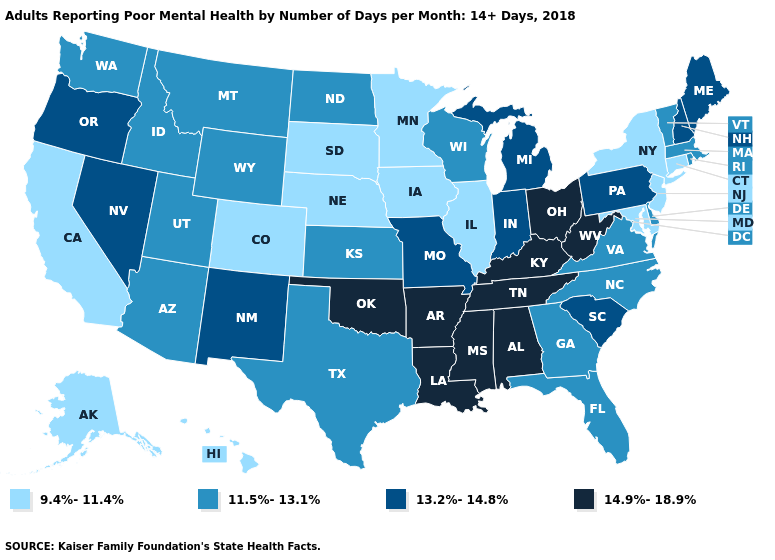Does Alabama have a lower value than Wisconsin?
Be succinct. No. What is the highest value in states that border Minnesota?
Quick response, please. 11.5%-13.1%. Does Hawaii have the same value as Minnesota?
Concise answer only. Yes. What is the value of Wyoming?
Concise answer only. 11.5%-13.1%. Name the states that have a value in the range 11.5%-13.1%?
Keep it brief. Arizona, Delaware, Florida, Georgia, Idaho, Kansas, Massachusetts, Montana, North Carolina, North Dakota, Rhode Island, Texas, Utah, Vermont, Virginia, Washington, Wisconsin, Wyoming. What is the lowest value in states that border Nebraska?
Keep it brief. 9.4%-11.4%. Name the states that have a value in the range 11.5%-13.1%?
Concise answer only. Arizona, Delaware, Florida, Georgia, Idaho, Kansas, Massachusetts, Montana, North Carolina, North Dakota, Rhode Island, Texas, Utah, Vermont, Virginia, Washington, Wisconsin, Wyoming. What is the highest value in the MidWest ?
Short answer required. 14.9%-18.9%. What is the highest value in the South ?
Give a very brief answer. 14.9%-18.9%. What is the value of California?
Be succinct. 9.4%-11.4%. Name the states that have a value in the range 9.4%-11.4%?
Write a very short answer. Alaska, California, Colorado, Connecticut, Hawaii, Illinois, Iowa, Maryland, Minnesota, Nebraska, New Jersey, New York, South Dakota. Does the first symbol in the legend represent the smallest category?
Quick response, please. Yes. Among the states that border Colorado , does Wyoming have the lowest value?
Write a very short answer. No. Name the states that have a value in the range 11.5%-13.1%?
Write a very short answer. Arizona, Delaware, Florida, Georgia, Idaho, Kansas, Massachusetts, Montana, North Carolina, North Dakota, Rhode Island, Texas, Utah, Vermont, Virginia, Washington, Wisconsin, Wyoming. Among the states that border North Carolina , does South Carolina have the highest value?
Keep it brief. No. 